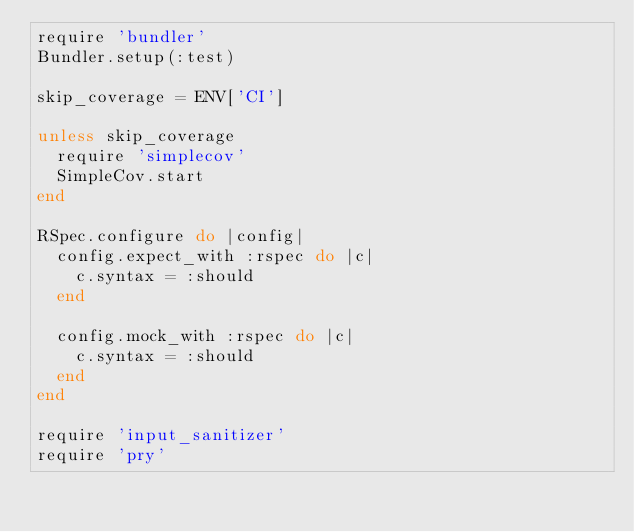Convert code to text. <code><loc_0><loc_0><loc_500><loc_500><_Ruby_>require 'bundler'
Bundler.setup(:test)

skip_coverage = ENV['CI']

unless skip_coverage
  require 'simplecov'
  SimpleCov.start
end

RSpec.configure do |config|
  config.expect_with :rspec do |c|
    c.syntax = :should
  end

  config.mock_with :rspec do |c|
    c.syntax = :should
  end
end

require 'input_sanitizer'
require 'pry'
</code> 